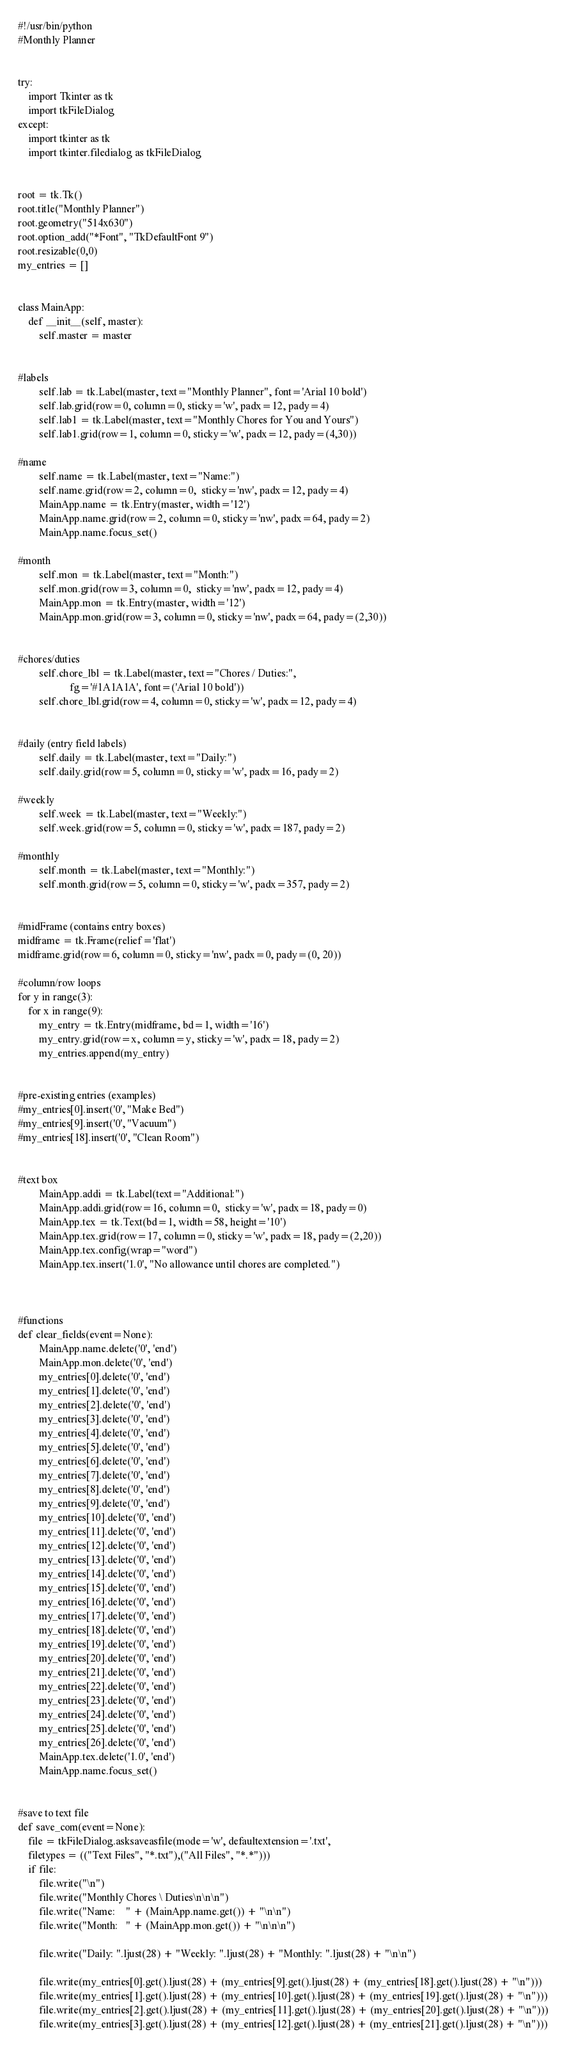Convert code to text. <code><loc_0><loc_0><loc_500><loc_500><_Python_>#!/usr/bin/python
#Monthly Planner


try:
	import Tkinter as tk
	import tkFileDialog
except:
	import tkinter as tk
	import tkinter.filedialog as tkFileDialog


root = tk.Tk()
root.title("Monthly Planner")
root.geometry("514x630")
root.option_add("*Font", "TkDefaultFont 9")
root.resizable(0,0)
my_entries = []


class MainApp:
	def __init__(self, master):
		self.master = master


#labels
		self.lab = tk.Label(master, text="Monthly Planner", font='Arial 10 bold')
		self.lab.grid(row=0, column=0, sticky='w', padx=12, pady=4)
		self.lab1 = tk.Label(master, text="Monthly Chores for You and Yours")
		self.lab1.grid(row=1, column=0, sticky='w', padx=12, pady=(4,30))

#name
		self.name = tk.Label(master, text="Name:")
		self.name.grid(row=2, column=0,  sticky='nw', padx=12, pady=4)
		MainApp.name = tk.Entry(master, width='12')
		MainApp.name.grid(row=2, column=0, sticky='nw', padx=64, pady=2)
		MainApp.name.focus_set()

#month
		self.mon = tk.Label(master, text="Month:")
		self.mon.grid(row=3, column=0,  sticky='nw', padx=12, pady=4)
		MainApp.mon = tk.Entry(master, width='12')
		MainApp.mon.grid(row=3, column=0, sticky='nw', padx=64, pady=(2,30))


#chores/duties
		self.chore_lbl = tk.Label(master, text="Chores / Duties:",
					fg='#1A1A1A', font=('Arial 10 bold'))
		self.chore_lbl.grid(row=4, column=0, sticky='w', padx=12, pady=4)


#daily (entry field labels)
		self.daily = tk.Label(master, text="Daily:")
		self.daily.grid(row=5, column=0, sticky='w', padx=16, pady=2)

#weekly
		self.week = tk.Label(master, text="Weekly:")
		self.week.grid(row=5, column=0, sticky='w', padx=187, pady=2)

#monthly
		self.month = tk.Label(master, text="Monthly:")
		self.month.grid(row=5, column=0, sticky='w', padx=357, pady=2)


#midFrame (contains entry boxes)
midframe = tk.Frame(relief='flat')
midframe.grid(row=6, column=0, sticky='nw', padx=0, pady=(0, 20))

#column/row loops
for y in range(3):
	for x in range(9):
		my_entry = tk.Entry(midframe, bd=1, width='16')
		my_entry.grid(row=x, column=y, sticky='w', padx=18, pady=2)
		my_entries.append(my_entry)


#pre-existing entries (examples)
#my_entries[0].insert('0', "Make Bed")
#my_entries[9].insert('0', "Vacuum")
#my_entries[18].insert('0', "Clean Room")


#text box
		MainApp.addi = tk.Label(text="Additional:")
		MainApp.addi.grid(row=16, column=0,  sticky='w', padx=18, pady=0)
		MainApp.tex = tk.Text(bd=1, width=58, height='10')
		MainApp.tex.grid(row=17, column=0, sticky='w', padx=18, pady=(2,20))
		MainApp.tex.config(wrap="word")
		MainApp.tex.insert('1.0', "No allowance until chores are completed.")



#functions
def clear_fields(event=None):
		MainApp.name.delete('0', 'end')
		MainApp.mon.delete('0', 'end')
		my_entries[0].delete('0', 'end')
		my_entries[1].delete('0', 'end')
		my_entries[2].delete('0', 'end')
		my_entries[3].delete('0', 'end')
		my_entries[4].delete('0', 'end')
		my_entries[5].delete('0', 'end')
		my_entries[6].delete('0', 'end')
		my_entries[7].delete('0', 'end')
		my_entries[8].delete('0', 'end')
		my_entries[9].delete('0', 'end')
		my_entries[10].delete('0', 'end')
		my_entries[11].delete('0', 'end')
		my_entries[12].delete('0', 'end')
		my_entries[13].delete('0', 'end')
		my_entries[14].delete('0', 'end')
		my_entries[15].delete('0', 'end')
		my_entries[16].delete('0', 'end')
		my_entries[17].delete('0', 'end')
		my_entries[18].delete('0', 'end')
		my_entries[19].delete('0', 'end')
		my_entries[20].delete('0', 'end')
		my_entries[21].delete('0', 'end')
		my_entries[22].delete('0', 'end')
		my_entries[23].delete('0', 'end')
		my_entries[24].delete('0', 'end')
		my_entries[25].delete('0', 'end')
		my_entries[26].delete('0', 'end')
		MainApp.tex.delete('1.0', 'end')
		MainApp.name.focus_set()


#save to text file
def save_com(event=None):
	file = tkFileDialog.asksaveasfile(mode='w', defaultextension='.txt',
	filetypes = (("Text Files", "*.txt"),("All Files", "*.*")))
	if file:
		file.write("\n")
		file.write("Monthly Chores \ Duties\n\n\n")
		file.write("Name:    " + (MainApp.name.get()) + "\n\n")
		file.write("Month:   " + (MainApp.mon.get()) + "\n\n\n")

		file.write("Daily: ".ljust(28) + "Weekly: ".ljust(28) + "Monthly: ".ljust(28) + "\n\n")

		file.write(my_entries[0].get().ljust(28) + (my_entries[9].get().ljust(28) + (my_entries[18].get().ljust(28) + "\n")))
		file.write(my_entries[1].get().ljust(28) + (my_entries[10].get().ljust(28) + (my_entries[19].get().ljust(28) + "\n")))
		file.write(my_entries[2].get().ljust(28) + (my_entries[11].get().ljust(28) + (my_entries[20].get().ljust(28) + "\n")))
		file.write(my_entries[3].get().ljust(28) + (my_entries[12].get().ljust(28) + (my_entries[21].get().ljust(28) + "\n")))</code> 